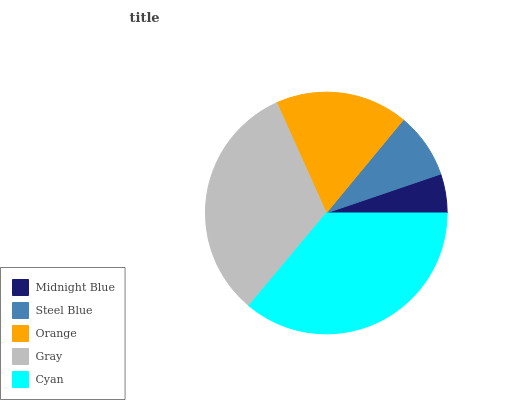Is Midnight Blue the minimum?
Answer yes or no. Yes. Is Cyan the maximum?
Answer yes or no. Yes. Is Steel Blue the minimum?
Answer yes or no. No. Is Steel Blue the maximum?
Answer yes or no. No. Is Steel Blue greater than Midnight Blue?
Answer yes or no. Yes. Is Midnight Blue less than Steel Blue?
Answer yes or no. Yes. Is Midnight Blue greater than Steel Blue?
Answer yes or no. No. Is Steel Blue less than Midnight Blue?
Answer yes or no. No. Is Orange the high median?
Answer yes or no. Yes. Is Orange the low median?
Answer yes or no. Yes. Is Midnight Blue the high median?
Answer yes or no. No. Is Midnight Blue the low median?
Answer yes or no. No. 